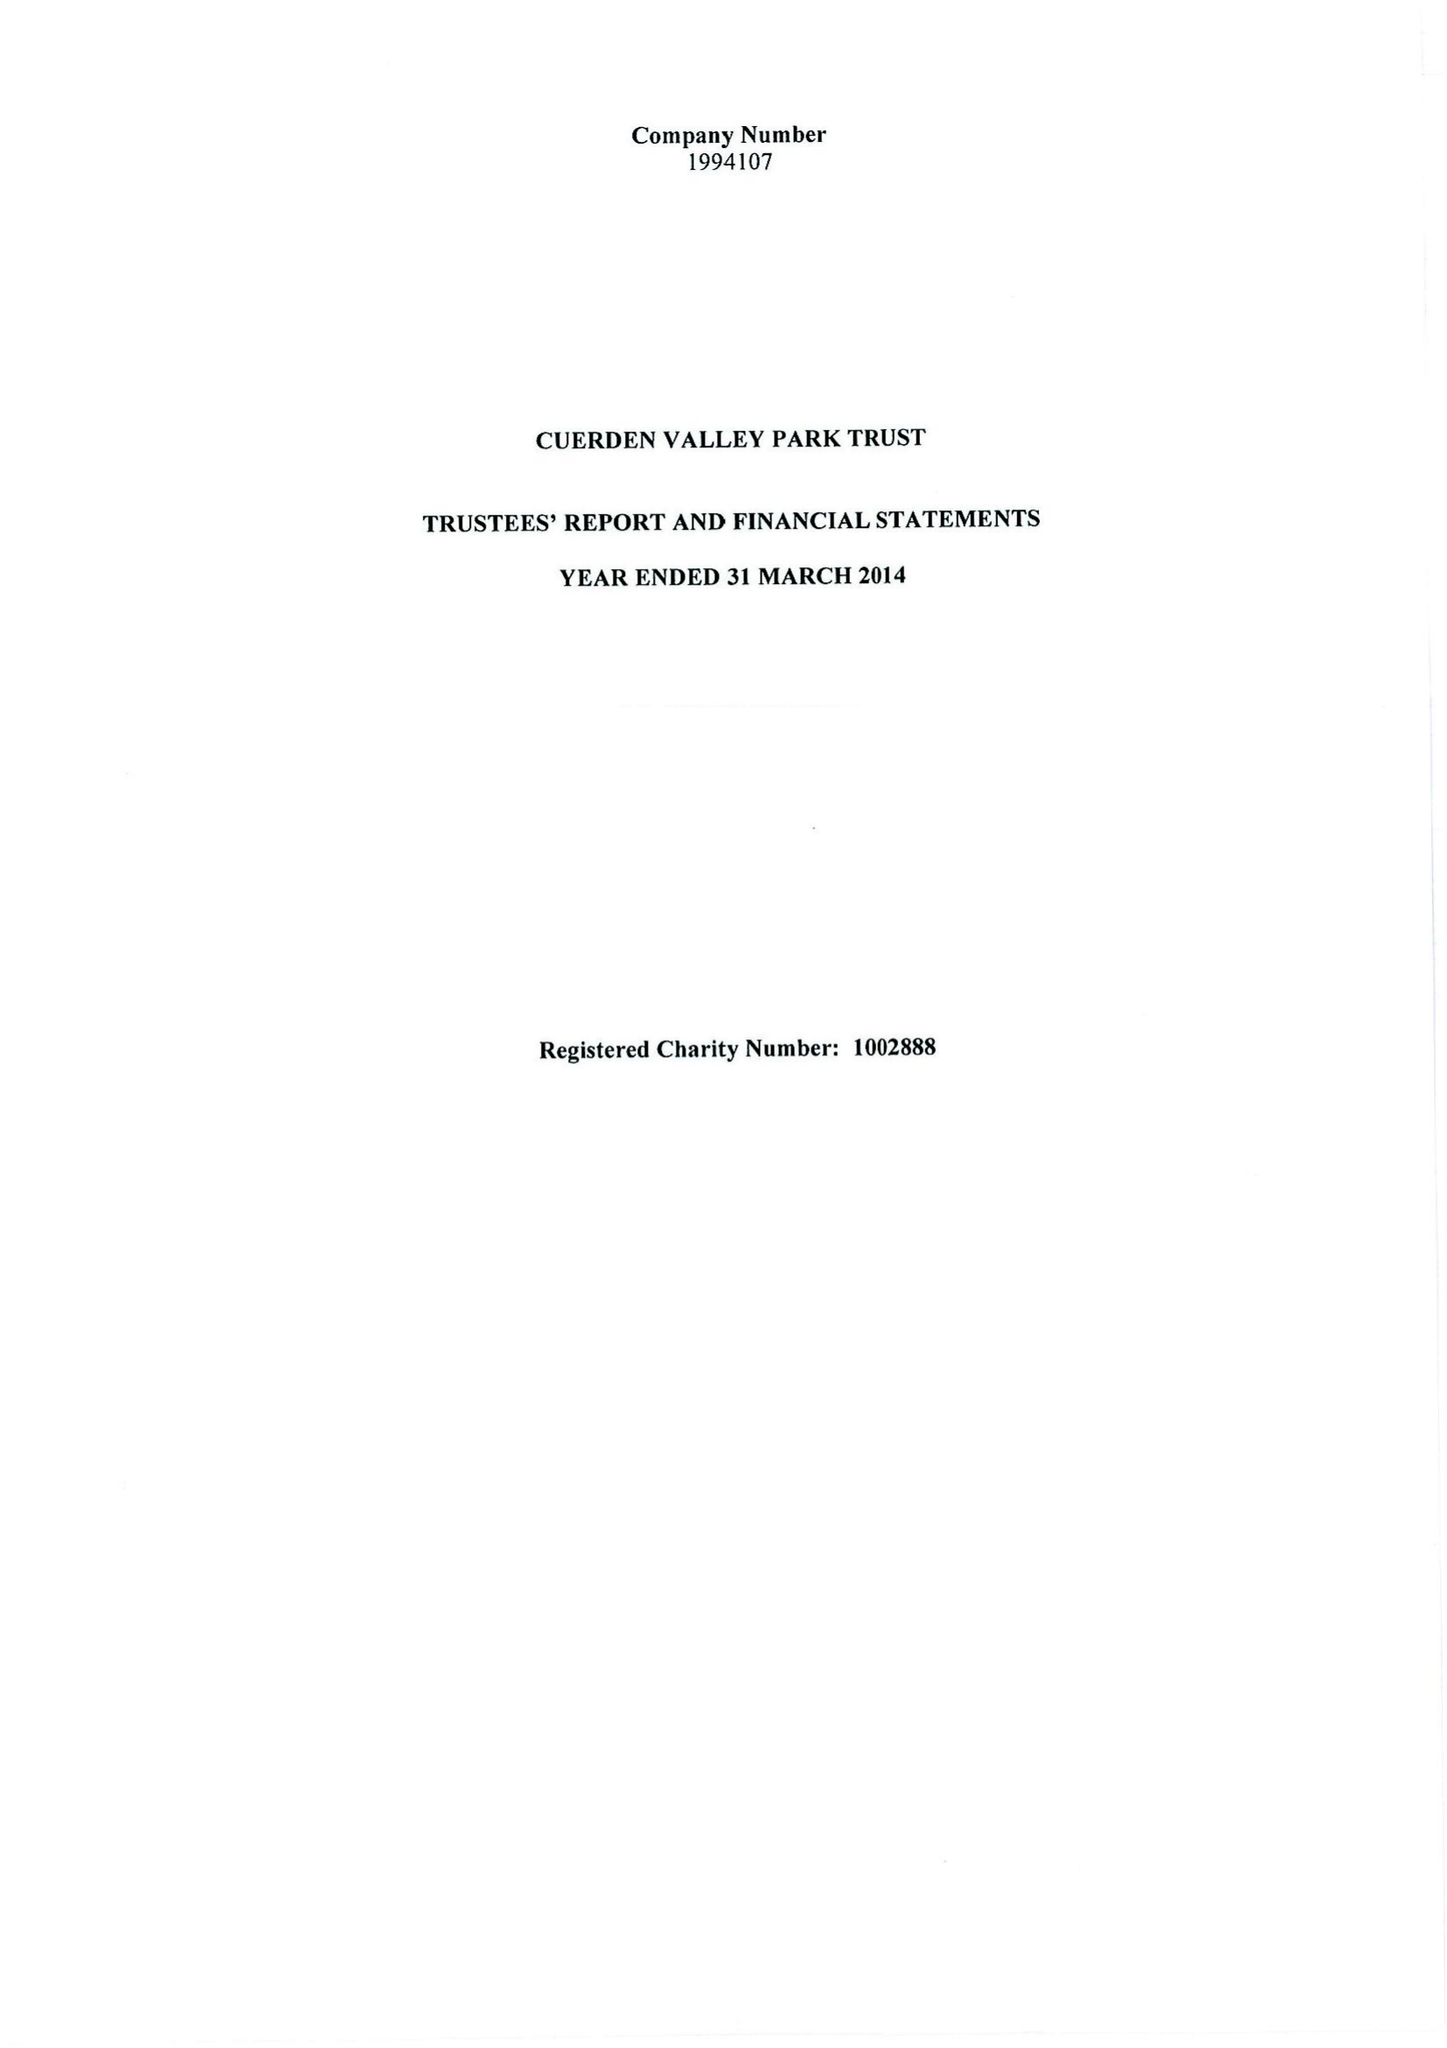What is the value for the income_annually_in_british_pounds?
Answer the question using a single word or phrase. 433915.00 